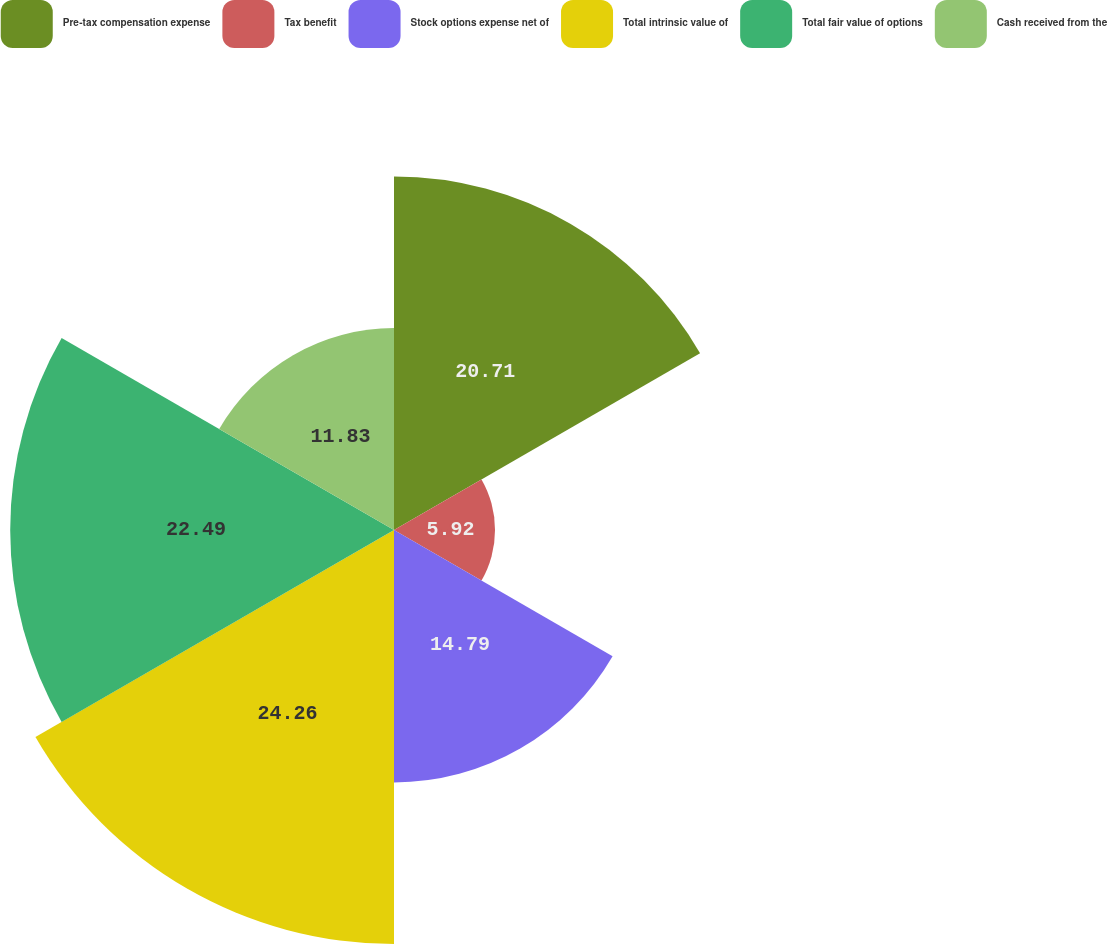Convert chart to OTSL. <chart><loc_0><loc_0><loc_500><loc_500><pie_chart><fcel>Pre-tax compensation expense<fcel>Tax benefit<fcel>Stock options expense net of<fcel>Total intrinsic value of<fcel>Total fair value of options<fcel>Cash received from the<nl><fcel>20.71%<fcel>5.92%<fcel>14.79%<fcel>24.26%<fcel>22.49%<fcel>11.83%<nl></chart> 